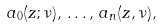<formula> <loc_0><loc_0><loc_500><loc_500>a _ { 0 } ( z ; \nu ) , \, \dots , \, a _ { n } ( z , \nu ) ,</formula> 